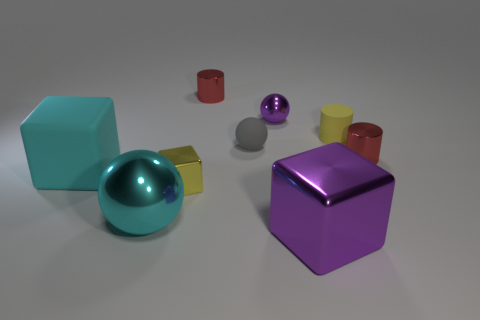Are there fewer large purple blocks behind the tiny yellow block than tiny purple cylinders?
Provide a succinct answer. No. The yellow object to the right of the tiny yellow cube has what shape?
Ensure brevity in your answer.  Cylinder. The big metallic thing right of the metallic block that is to the left of the red object that is on the left side of the big shiny cube is what shape?
Provide a succinct answer. Cube. How many objects are green matte cubes or metallic balls?
Your answer should be compact. 2. There is a red metal thing to the right of the purple cube; does it have the same shape as the small yellow thing to the left of the small purple metal object?
Ensure brevity in your answer.  No. How many things are in front of the yellow metal thing and right of the big cyan ball?
Ensure brevity in your answer.  1. How many other objects are the same size as the matte ball?
Offer a very short reply. 5. There is a large thing that is in front of the yellow metal cube and left of the big purple shiny block; what is its material?
Your answer should be very brief. Metal. There is a rubber cube; is it the same color as the shiny sphere that is in front of the rubber cube?
Offer a terse response. Yes. The purple shiny thing that is the same shape as the big cyan shiny object is what size?
Keep it short and to the point. Small. 